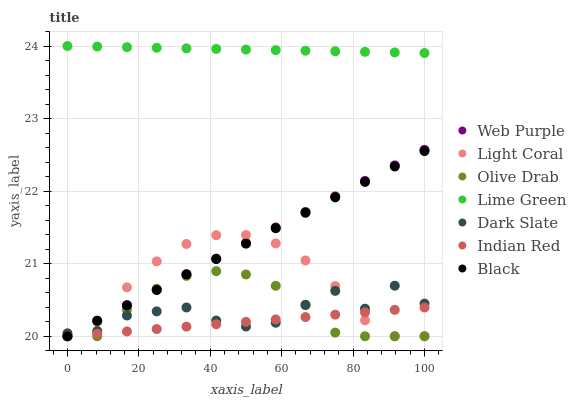Does Indian Red have the minimum area under the curve?
Answer yes or no. Yes. Does Lime Green have the maximum area under the curve?
Answer yes or no. Yes. Does Dark Slate have the minimum area under the curve?
Answer yes or no. No. Does Dark Slate have the maximum area under the curve?
Answer yes or no. No. Is Web Purple the smoothest?
Answer yes or no. Yes. Is Dark Slate the roughest?
Answer yes or no. Yes. Is Dark Slate the smoothest?
Answer yes or no. No. Is Web Purple the roughest?
Answer yes or no. No. Does Light Coral have the lowest value?
Answer yes or no. Yes. Does Dark Slate have the lowest value?
Answer yes or no. No. Does Lime Green have the highest value?
Answer yes or no. Yes. Does Dark Slate have the highest value?
Answer yes or no. No. Is Indian Red less than Lime Green?
Answer yes or no. Yes. Is Lime Green greater than Indian Red?
Answer yes or no. Yes. Does Indian Red intersect Light Coral?
Answer yes or no. Yes. Is Indian Red less than Light Coral?
Answer yes or no. No. Is Indian Red greater than Light Coral?
Answer yes or no. No. Does Indian Red intersect Lime Green?
Answer yes or no. No. 